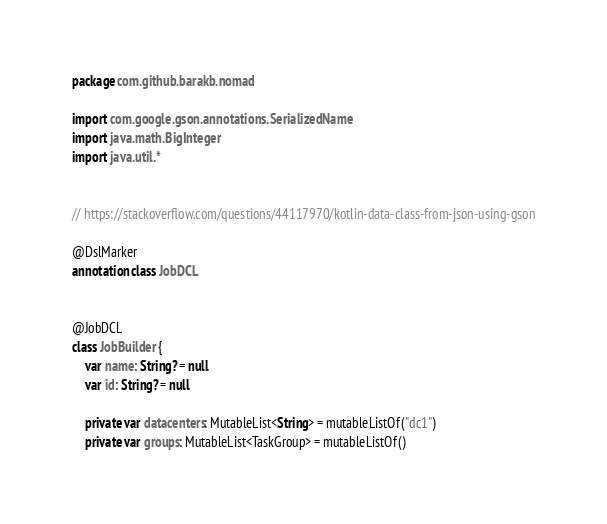<code> <loc_0><loc_0><loc_500><loc_500><_Kotlin_>package com.github.barakb.nomad

import com.google.gson.annotations.SerializedName
import java.math.BigInteger
import java.util.*


// https://stackoverflow.com/questions/44117970/kotlin-data-class-from-json-using-gson

@DslMarker
annotation class JobDCL


@JobDCL
class JobBuilder {
    var name: String? = null
    var id: String? = null

    private var datacenters: MutableList<String> = mutableListOf("dc1")
    private var groups: MutableList<TaskGroup> = mutableListOf()
</code> 